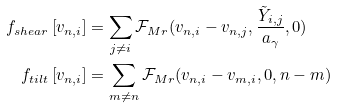<formula> <loc_0><loc_0><loc_500><loc_500>f _ { s h e a r } \left [ v _ { n , i } \right ] & = \sum _ { j \neq i } \mathcal { F } _ { M r } ( v _ { n , i } - v _ { n , j } , \frac { \tilde { Y } _ { i , j } } { a _ { \gamma } } , 0 ) \\ f _ { t i l t } \left [ v _ { n , i } \right ] & = \sum _ { m \neq n } \mathcal { F } _ { M r } ( v _ { n , i } - v _ { m , i } , 0 , n - m )</formula> 